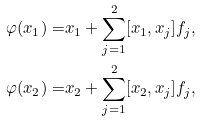Convert formula to latex. <formula><loc_0><loc_0><loc_500><loc_500>\varphi ( x _ { 1 } ) = & x _ { 1 } + \sum _ { j = 1 } ^ { 2 } [ x _ { 1 } , x _ { j } ] f _ { j } , \\ \varphi ( x _ { 2 } ) = & x _ { 2 } + \sum _ { j = 1 } ^ { 2 } [ x _ { 2 } , x _ { j } ] f _ { j } ,</formula> 